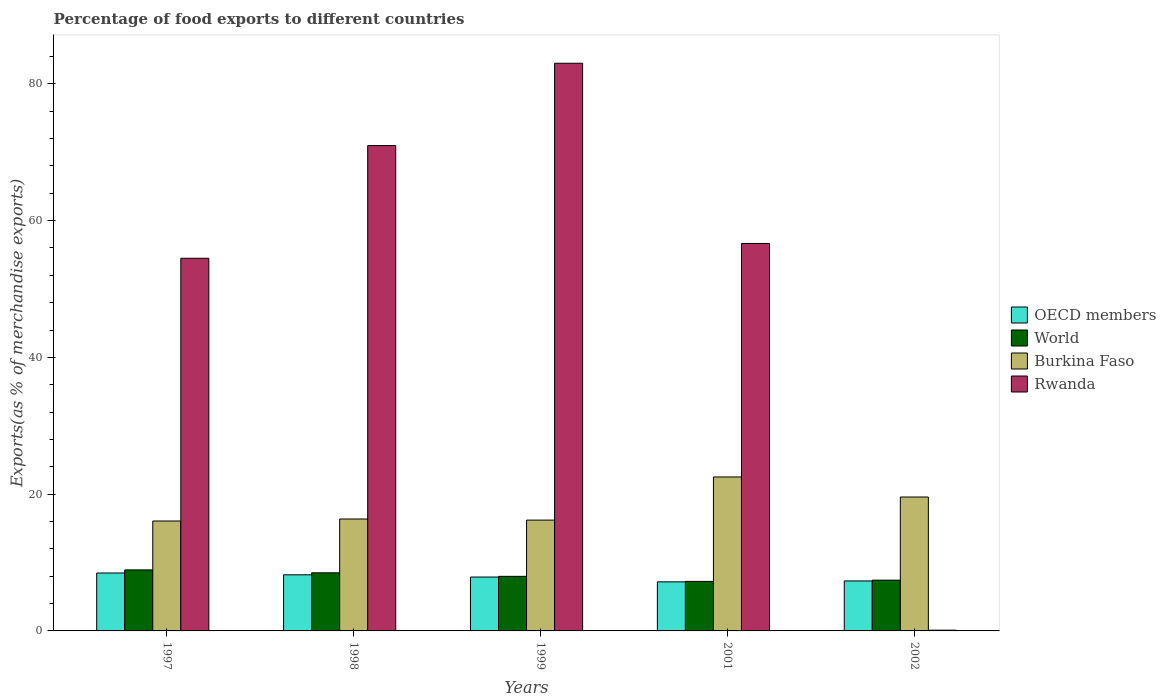How many different coloured bars are there?
Keep it short and to the point. 4. How many groups of bars are there?
Make the answer very short. 5. How many bars are there on the 1st tick from the left?
Ensure brevity in your answer.  4. What is the percentage of exports to different countries in Burkina Faso in 2002?
Make the answer very short. 19.58. Across all years, what is the maximum percentage of exports to different countries in Burkina Faso?
Make the answer very short. 22.51. Across all years, what is the minimum percentage of exports to different countries in Burkina Faso?
Provide a short and direct response. 16.07. In which year was the percentage of exports to different countries in OECD members minimum?
Provide a short and direct response. 2001. What is the total percentage of exports to different countries in World in the graph?
Your answer should be very brief. 40.06. What is the difference between the percentage of exports to different countries in Rwanda in 1997 and that in 2001?
Your response must be concise. -2.16. What is the difference between the percentage of exports to different countries in Rwanda in 1997 and the percentage of exports to different countries in OECD members in 2001?
Give a very brief answer. 47.32. What is the average percentage of exports to different countries in Rwanda per year?
Your response must be concise. 53.05. In the year 1999, what is the difference between the percentage of exports to different countries in OECD members and percentage of exports to different countries in Burkina Faso?
Provide a succinct answer. -8.33. What is the ratio of the percentage of exports to different countries in OECD members in 1997 to that in 1999?
Offer a very short reply. 1.07. Is the percentage of exports to different countries in Burkina Faso in 1998 less than that in 2001?
Your response must be concise. Yes. Is the difference between the percentage of exports to different countries in OECD members in 2001 and 2002 greater than the difference between the percentage of exports to different countries in Burkina Faso in 2001 and 2002?
Provide a succinct answer. No. What is the difference between the highest and the second highest percentage of exports to different countries in OECD members?
Offer a very short reply. 0.26. What is the difference between the highest and the lowest percentage of exports to different countries in World?
Give a very brief answer. 1.68. Is the sum of the percentage of exports to different countries in Rwanda in 2001 and 2002 greater than the maximum percentage of exports to different countries in OECD members across all years?
Offer a very short reply. Yes. What does the 2nd bar from the left in 2002 represents?
Your answer should be compact. World. What does the 2nd bar from the right in 1999 represents?
Offer a terse response. Burkina Faso. How many bars are there?
Offer a terse response. 20. Are all the bars in the graph horizontal?
Provide a succinct answer. No. How many years are there in the graph?
Your answer should be compact. 5. Are the values on the major ticks of Y-axis written in scientific E-notation?
Keep it short and to the point. No. How are the legend labels stacked?
Your answer should be compact. Vertical. What is the title of the graph?
Keep it short and to the point. Percentage of food exports to different countries. What is the label or title of the X-axis?
Ensure brevity in your answer.  Years. What is the label or title of the Y-axis?
Make the answer very short. Exports(as % of merchandise exports). What is the Exports(as % of merchandise exports) of OECD members in 1997?
Your response must be concise. 8.47. What is the Exports(as % of merchandise exports) of World in 1997?
Offer a terse response. 8.92. What is the Exports(as % of merchandise exports) in Burkina Faso in 1997?
Your response must be concise. 16.07. What is the Exports(as % of merchandise exports) in Rwanda in 1997?
Your answer should be very brief. 54.49. What is the Exports(as % of merchandise exports) in OECD members in 1998?
Make the answer very short. 8.2. What is the Exports(as % of merchandise exports) of World in 1998?
Provide a succinct answer. 8.5. What is the Exports(as % of merchandise exports) in Burkina Faso in 1998?
Provide a succinct answer. 16.37. What is the Exports(as % of merchandise exports) in Rwanda in 1998?
Provide a short and direct response. 70.97. What is the Exports(as % of merchandise exports) of OECD members in 1999?
Your response must be concise. 7.88. What is the Exports(as % of merchandise exports) in World in 1999?
Give a very brief answer. 7.98. What is the Exports(as % of merchandise exports) of Burkina Faso in 1999?
Provide a succinct answer. 16.2. What is the Exports(as % of merchandise exports) of Rwanda in 1999?
Your answer should be very brief. 83.01. What is the Exports(as % of merchandise exports) in OECD members in 2001?
Offer a terse response. 7.17. What is the Exports(as % of merchandise exports) of World in 2001?
Keep it short and to the point. 7.24. What is the Exports(as % of merchandise exports) in Burkina Faso in 2001?
Keep it short and to the point. 22.51. What is the Exports(as % of merchandise exports) in Rwanda in 2001?
Offer a terse response. 56.66. What is the Exports(as % of merchandise exports) of OECD members in 2002?
Offer a terse response. 7.31. What is the Exports(as % of merchandise exports) of World in 2002?
Provide a short and direct response. 7.42. What is the Exports(as % of merchandise exports) of Burkina Faso in 2002?
Ensure brevity in your answer.  19.58. What is the Exports(as % of merchandise exports) of Rwanda in 2002?
Give a very brief answer. 0.11. Across all years, what is the maximum Exports(as % of merchandise exports) in OECD members?
Offer a terse response. 8.47. Across all years, what is the maximum Exports(as % of merchandise exports) of World?
Make the answer very short. 8.92. Across all years, what is the maximum Exports(as % of merchandise exports) of Burkina Faso?
Ensure brevity in your answer.  22.51. Across all years, what is the maximum Exports(as % of merchandise exports) in Rwanda?
Give a very brief answer. 83.01. Across all years, what is the minimum Exports(as % of merchandise exports) of OECD members?
Your answer should be very brief. 7.17. Across all years, what is the minimum Exports(as % of merchandise exports) of World?
Your response must be concise. 7.24. Across all years, what is the minimum Exports(as % of merchandise exports) in Burkina Faso?
Keep it short and to the point. 16.07. Across all years, what is the minimum Exports(as % of merchandise exports) in Rwanda?
Your answer should be very brief. 0.11. What is the total Exports(as % of merchandise exports) in OECD members in the graph?
Your response must be concise. 39.04. What is the total Exports(as % of merchandise exports) of World in the graph?
Offer a very short reply. 40.06. What is the total Exports(as % of merchandise exports) in Burkina Faso in the graph?
Offer a terse response. 90.74. What is the total Exports(as % of merchandise exports) in Rwanda in the graph?
Offer a terse response. 265.23. What is the difference between the Exports(as % of merchandise exports) of OECD members in 1997 and that in 1998?
Your answer should be very brief. 0.26. What is the difference between the Exports(as % of merchandise exports) of World in 1997 and that in 1998?
Give a very brief answer. 0.43. What is the difference between the Exports(as % of merchandise exports) of Burkina Faso in 1997 and that in 1998?
Give a very brief answer. -0.29. What is the difference between the Exports(as % of merchandise exports) of Rwanda in 1997 and that in 1998?
Offer a terse response. -16.48. What is the difference between the Exports(as % of merchandise exports) of OECD members in 1997 and that in 1999?
Your response must be concise. 0.59. What is the difference between the Exports(as % of merchandise exports) of Burkina Faso in 1997 and that in 1999?
Provide a succinct answer. -0.13. What is the difference between the Exports(as % of merchandise exports) of Rwanda in 1997 and that in 1999?
Give a very brief answer. -28.51. What is the difference between the Exports(as % of merchandise exports) of OECD members in 1997 and that in 2001?
Give a very brief answer. 1.29. What is the difference between the Exports(as % of merchandise exports) of World in 1997 and that in 2001?
Your answer should be very brief. 1.68. What is the difference between the Exports(as % of merchandise exports) in Burkina Faso in 1997 and that in 2001?
Give a very brief answer. -6.44. What is the difference between the Exports(as % of merchandise exports) of Rwanda in 1997 and that in 2001?
Ensure brevity in your answer.  -2.16. What is the difference between the Exports(as % of merchandise exports) in OECD members in 1997 and that in 2002?
Make the answer very short. 1.16. What is the difference between the Exports(as % of merchandise exports) of World in 1997 and that in 2002?
Offer a very short reply. 1.5. What is the difference between the Exports(as % of merchandise exports) in Burkina Faso in 1997 and that in 2002?
Keep it short and to the point. -3.51. What is the difference between the Exports(as % of merchandise exports) in Rwanda in 1997 and that in 2002?
Provide a succinct answer. 54.38. What is the difference between the Exports(as % of merchandise exports) of OECD members in 1998 and that in 1999?
Provide a short and direct response. 0.33. What is the difference between the Exports(as % of merchandise exports) in World in 1998 and that in 1999?
Your response must be concise. 0.52. What is the difference between the Exports(as % of merchandise exports) in Burkina Faso in 1998 and that in 1999?
Offer a very short reply. 0.16. What is the difference between the Exports(as % of merchandise exports) in Rwanda in 1998 and that in 1999?
Make the answer very short. -12.04. What is the difference between the Exports(as % of merchandise exports) in OECD members in 1998 and that in 2001?
Keep it short and to the point. 1.03. What is the difference between the Exports(as % of merchandise exports) in World in 1998 and that in 2001?
Keep it short and to the point. 1.26. What is the difference between the Exports(as % of merchandise exports) in Burkina Faso in 1998 and that in 2001?
Your answer should be very brief. -6.15. What is the difference between the Exports(as % of merchandise exports) of Rwanda in 1998 and that in 2001?
Your answer should be very brief. 14.31. What is the difference between the Exports(as % of merchandise exports) of OECD members in 1998 and that in 2002?
Offer a terse response. 0.9. What is the difference between the Exports(as % of merchandise exports) of World in 1998 and that in 2002?
Offer a very short reply. 1.07. What is the difference between the Exports(as % of merchandise exports) of Burkina Faso in 1998 and that in 2002?
Provide a short and direct response. -3.21. What is the difference between the Exports(as % of merchandise exports) of Rwanda in 1998 and that in 2002?
Ensure brevity in your answer.  70.86. What is the difference between the Exports(as % of merchandise exports) in OECD members in 1999 and that in 2001?
Offer a very short reply. 0.7. What is the difference between the Exports(as % of merchandise exports) in World in 1999 and that in 2001?
Make the answer very short. 0.74. What is the difference between the Exports(as % of merchandise exports) in Burkina Faso in 1999 and that in 2001?
Your answer should be compact. -6.31. What is the difference between the Exports(as % of merchandise exports) in Rwanda in 1999 and that in 2001?
Give a very brief answer. 26.35. What is the difference between the Exports(as % of merchandise exports) in OECD members in 1999 and that in 2002?
Offer a very short reply. 0.57. What is the difference between the Exports(as % of merchandise exports) in World in 1999 and that in 2002?
Your answer should be compact. 0.55. What is the difference between the Exports(as % of merchandise exports) of Burkina Faso in 1999 and that in 2002?
Ensure brevity in your answer.  -3.38. What is the difference between the Exports(as % of merchandise exports) of Rwanda in 1999 and that in 2002?
Your answer should be very brief. 82.9. What is the difference between the Exports(as % of merchandise exports) in OECD members in 2001 and that in 2002?
Provide a short and direct response. -0.13. What is the difference between the Exports(as % of merchandise exports) of World in 2001 and that in 2002?
Your answer should be very brief. -0.19. What is the difference between the Exports(as % of merchandise exports) of Burkina Faso in 2001 and that in 2002?
Ensure brevity in your answer.  2.93. What is the difference between the Exports(as % of merchandise exports) of Rwanda in 2001 and that in 2002?
Provide a short and direct response. 56.55. What is the difference between the Exports(as % of merchandise exports) of OECD members in 1997 and the Exports(as % of merchandise exports) of World in 1998?
Keep it short and to the point. -0.03. What is the difference between the Exports(as % of merchandise exports) in OECD members in 1997 and the Exports(as % of merchandise exports) in Burkina Faso in 1998?
Your answer should be very brief. -7.9. What is the difference between the Exports(as % of merchandise exports) in OECD members in 1997 and the Exports(as % of merchandise exports) in Rwanda in 1998?
Offer a very short reply. -62.5. What is the difference between the Exports(as % of merchandise exports) in World in 1997 and the Exports(as % of merchandise exports) in Burkina Faso in 1998?
Keep it short and to the point. -7.44. What is the difference between the Exports(as % of merchandise exports) of World in 1997 and the Exports(as % of merchandise exports) of Rwanda in 1998?
Make the answer very short. -62.05. What is the difference between the Exports(as % of merchandise exports) of Burkina Faso in 1997 and the Exports(as % of merchandise exports) of Rwanda in 1998?
Provide a short and direct response. -54.9. What is the difference between the Exports(as % of merchandise exports) of OECD members in 1997 and the Exports(as % of merchandise exports) of World in 1999?
Provide a succinct answer. 0.49. What is the difference between the Exports(as % of merchandise exports) of OECD members in 1997 and the Exports(as % of merchandise exports) of Burkina Faso in 1999?
Offer a very short reply. -7.74. What is the difference between the Exports(as % of merchandise exports) in OECD members in 1997 and the Exports(as % of merchandise exports) in Rwanda in 1999?
Give a very brief answer. -74.54. What is the difference between the Exports(as % of merchandise exports) in World in 1997 and the Exports(as % of merchandise exports) in Burkina Faso in 1999?
Your answer should be compact. -7.28. What is the difference between the Exports(as % of merchandise exports) in World in 1997 and the Exports(as % of merchandise exports) in Rwanda in 1999?
Ensure brevity in your answer.  -74.08. What is the difference between the Exports(as % of merchandise exports) in Burkina Faso in 1997 and the Exports(as % of merchandise exports) in Rwanda in 1999?
Offer a terse response. -66.93. What is the difference between the Exports(as % of merchandise exports) of OECD members in 1997 and the Exports(as % of merchandise exports) of World in 2001?
Provide a succinct answer. 1.23. What is the difference between the Exports(as % of merchandise exports) of OECD members in 1997 and the Exports(as % of merchandise exports) of Burkina Faso in 2001?
Provide a succinct answer. -14.04. What is the difference between the Exports(as % of merchandise exports) in OECD members in 1997 and the Exports(as % of merchandise exports) in Rwanda in 2001?
Give a very brief answer. -48.19. What is the difference between the Exports(as % of merchandise exports) of World in 1997 and the Exports(as % of merchandise exports) of Burkina Faso in 2001?
Make the answer very short. -13.59. What is the difference between the Exports(as % of merchandise exports) in World in 1997 and the Exports(as % of merchandise exports) in Rwanda in 2001?
Make the answer very short. -47.73. What is the difference between the Exports(as % of merchandise exports) of Burkina Faso in 1997 and the Exports(as % of merchandise exports) of Rwanda in 2001?
Provide a short and direct response. -40.58. What is the difference between the Exports(as % of merchandise exports) of OECD members in 1997 and the Exports(as % of merchandise exports) of World in 2002?
Your answer should be very brief. 1.04. What is the difference between the Exports(as % of merchandise exports) in OECD members in 1997 and the Exports(as % of merchandise exports) in Burkina Faso in 2002?
Your answer should be compact. -11.11. What is the difference between the Exports(as % of merchandise exports) of OECD members in 1997 and the Exports(as % of merchandise exports) of Rwanda in 2002?
Offer a terse response. 8.36. What is the difference between the Exports(as % of merchandise exports) in World in 1997 and the Exports(as % of merchandise exports) in Burkina Faso in 2002?
Keep it short and to the point. -10.66. What is the difference between the Exports(as % of merchandise exports) in World in 1997 and the Exports(as % of merchandise exports) in Rwanda in 2002?
Provide a succinct answer. 8.82. What is the difference between the Exports(as % of merchandise exports) in Burkina Faso in 1997 and the Exports(as % of merchandise exports) in Rwanda in 2002?
Ensure brevity in your answer.  15.96. What is the difference between the Exports(as % of merchandise exports) of OECD members in 1998 and the Exports(as % of merchandise exports) of World in 1999?
Your response must be concise. 0.23. What is the difference between the Exports(as % of merchandise exports) of OECD members in 1998 and the Exports(as % of merchandise exports) of Burkina Faso in 1999?
Your answer should be very brief. -8. What is the difference between the Exports(as % of merchandise exports) in OECD members in 1998 and the Exports(as % of merchandise exports) in Rwanda in 1999?
Your answer should be very brief. -74.8. What is the difference between the Exports(as % of merchandise exports) of World in 1998 and the Exports(as % of merchandise exports) of Burkina Faso in 1999?
Provide a succinct answer. -7.71. What is the difference between the Exports(as % of merchandise exports) in World in 1998 and the Exports(as % of merchandise exports) in Rwanda in 1999?
Make the answer very short. -74.51. What is the difference between the Exports(as % of merchandise exports) of Burkina Faso in 1998 and the Exports(as % of merchandise exports) of Rwanda in 1999?
Provide a short and direct response. -66.64. What is the difference between the Exports(as % of merchandise exports) in OECD members in 1998 and the Exports(as % of merchandise exports) in World in 2001?
Your response must be concise. 0.96. What is the difference between the Exports(as % of merchandise exports) in OECD members in 1998 and the Exports(as % of merchandise exports) in Burkina Faso in 2001?
Provide a succinct answer. -14.31. What is the difference between the Exports(as % of merchandise exports) in OECD members in 1998 and the Exports(as % of merchandise exports) in Rwanda in 2001?
Offer a terse response. -48.45. What is the difference between the Exports(as % of merchandise exports) of World in 1998 and the Exports(as % of merchandise exports) of Burkina Faso in 2001?
Your answer should be compact. -14.02. What is the difference between the Exports(as % of merchandise exports) in World in 1998 and the Exports(as % of merchandise exports) in Rwanda in 2001?
Provide a short and direct response. -48.16. What is the difference between the Exports(as % of merchandise exports) in Burkina Faso in 1998 and the Exports(as % of merchandise exports) in Rwanda in 2001?
Ensure brevity in your answer.  -40.29. What is the difference between the Exports(as % of merchandise exports) of OECD members in 1998 and the Exports(as % of merchandise exports) of World in 2002?
Offer a very short reply. 0.78. What is the difference between the Exports(as % of merchandise exports) of OECD members in 1998 and the Exports(as % of merchandise exports) of Burkina Faso in 2002?
Give a very brief answer. -11.38. What is the difference between the Exports(as % of merchandise exports) of OECD members in 1998 and the Exports(as % of merchandise exports) of Rwanda in 2002?
Your answer should be very brief. 8.1. What is the difference between the Exports(as % of merchandise exports) of World in 1998 and the Exports(as % of merchandise exports) of Burkina Faso in 2002?
Provide a succinct answer. -11.08. What is the difference between the Exports(as % of merchandise exports) of World in 1998 and the Exports(as % of merchandise exports) of Rwanda in 2002?
Your response must be concise. 8.39. What is the difference between the Exports(as % of merchandise exports) of Burkina Faso in 1998 and the Exports(as % of merchandise exports) of Rwanda in 2002?
Provide a short and direct response. 16.26. What is the difference between the Exports(as % of merchandise exports) of OECD members in 1999 and the Exports(as % of merchandise exports) of World in 2001?
Provide a succinct answer. 0.64. What is the difference between the Exports(as % of merchandise exports) of OECD members in 1999 and the Exports(as % of merchandise exports) of Burkina Faso in 2001?
Your response must be concise. -14.63. What is the difference between the Exports(as % of merchandise exports) of OECD members in 1999 and the Exports(as % of merchandise exports) of Rwanda in 2001?
Keep it short and to the point. -48.78. What is the difference between the Exports(as % of merchandise exports) in World in 1999 and the Exports(as % of merchandise exports) in Burkina Faso in 2001?
Provide a succinct answer. -14.53. What is the difference between the Exports(as % of merchandise exports) of World in 1999 and the Exports(as % of merchandise exports) of Rwanda in 2001?
Keep it short and to the point. -48.68. What is the difference between the Exports(as % of merchandise exports) of Burkina Faso in 1999 and the Exports(as % of merchandise exports) of Rwanda in 2001?
Your answer should be very brief. -40.45. What is the difference between the Exports(as % of merchandise exports) of OECD members in 1999 and the Exports(as % of merchandise exports) of World in 2002?
Ensure brevity in your answer.  0.45. What is the difference between the Exports(as % of merchandise exports) of OECD members in 1999 and the Exports(as % of merchandise exports) of Burkina Faso in 2002?
Ensure brevity in your answer.  -11.7. What is the difference between the Exports(as % of merchandise exports) in OECD members in 1999 and the Exports(as % of merchandise exports) in Rwanda in 2002?
Your answer should be very brief. 7.77. What is the difference between the Exports(as % of merchandise exports) of World in 1999 and the Exports(as % of merchandise exports) of Burkina Faso in 2002?
Provide a short and direct response. -11.6. What is the difference between the Exports(as % of merchandise exports) of World in 1999 and the Exports(as % of merchandise exports) of Rwanda in 2002?
Your response must be concise. 7.87. What is the difference between the Exports(as % of merchandise exports) in Burkina Faso in 1999 and the Exports(as % of merchandise exports) in Rwanda in 2002?
Ensure brevity in your answer.  16.1. What is the difference between the Exports(as % of merchandise exports) of OECD members in 2001 and the Exports(as % of merchandise exports) of World in 2002?
Your answer should be compact. -0.25. What is the difference between the Exports(as % of merchandise exports) of OECD members in 2001 and the Exports(as % of merchandise exports) of Burkina Faso in 2002?
Offer a terse response. -12.41. What is the difference between the Exports(as % of merchandise exports) in OECD members in 2001 and the Exports(as % of merchandise exports) in Rwanda in 2002?
Give a very brief answer. 7.07. What is the difference between the Exports(as % of merchandise exports) of World in 2001 and the Exports(as % of merchandise exports) of Burkina Faso in 2002?
Keep it short and to the point. -12.34. What is the difference between the Exports(as % of merchandise exports) of World in 2001 and the Exports(as % of merchandise exports) of Rwanda in 2002?
Offer a terse response. 7.13. What is the difference between the Exports(as % of merchandise exports) of Burkina Faso in 2001 and the Exports(as % of merchandise exports) of Rwanda in 2002?
Your answer should be compact. 22.4. What is the average Exports(as % of merchandise exports) in OECD members per year?
Offer a very short reply. 7.81. What is the average Exports(as % of merchandise exports) in World per year?
Your answer should be very brief. 8.01. What is the average Exports(as % of merchandise exports) of Burkina Faso per year?
Your answer should be compact. 18.15. What is the average Exports(as % of merchandise exports) of Rwanda per year?
Give a very brief answer. 53.05. In the year 1997, what is the difference between the Exports(as % of merchandise exports) of OECD members and Exports(as % of merchandise exports) of World?
Provide a short and direct response. -0.46. In the year 1997, what is the difference between the Exports(as % of merchandise exports) of OECD members and Exports(as % of merchandise exports) of Burkina Faso?
Provide a short and direct response. -7.6. In the year 1997, what is the difference between the Exports(as % of merchandise exports) in OECD members and Exports(as % of merchandise exports) in Rwanda?
Provide a succinct answer. -46.02. In the year 1997, what is the difference between the Exports(as % of merchandise exports) in World and Exports(as % of merchandise exports) in Burkina Faso?
Give a very brief answer. -7.15. In the year 1997, what is the difference between the Exports(as % of merchandise exports) in World and Exports(as % of merchandise exports) in Rwanda?
Your response must be concise. -45.57. In the year 1997, what is the difference between the Exports(as % of merchandise exports) in Burkina Faso and Exports(as % of merchandise exports) in Rwanda?
Keep it short and to the point. -38.42. In the year 1998, what is the difference between the Exports(as % of merchandise exports) of OECD members and Exports(as % of merchandise exports) of World?
Offer a terse response. -0.29. In the year 1998, what is the difference between the Exports(as % of merchandise exports) in OECD members and Exports(as % of merchandise exports) in Burkina Faso?
Offer a terse response. -8.16. In the year 1998, what is the difference between the Exports(as % of merchandise exports) of OECD members and Exports(as % of merchandise exports) of Rwanda?
Offer a terse response. -62.76. In the year 1998, what is the difference between the Exports(as % of merchandise exports) of World and Exports(as % of merchandise exports) of Burkina Faso?
Give a very brief answer. -7.87. In the year 1998, what is the difference between the Exports(as % of merchandise exports) in World and Exports(as % of merchandise exports) in Rwanda?
Offer a very short reply. -62.47. In the year 1998, what is the difference between the Exports(as % of merchandise exports) in Burkina Faso and Exports(as % of merchandise exports) in Rwanda?
Offer a very short reply. -54.6. In the year 1999, what is the difference between the Exports(as % of merchandise exports) in OECD members and Exports(as % of merchandise exports) in World?
Offer a terse response. -0.1. In the year 1999, what is the difference between the Exports(as % of merchandise exports) of OECD members and Exports(as % of merchandise exports) of Burkina Faso?
Ensure brevity in your answer.  -8.33. In the year 1999, what is the difference between the Exports(as % of merchandise exports) in OECD members and Exports(as % of merchandise exports) in Rwanda?
Provide a succinct answer. -75.13. In the year 1999, what is the difference between the Exports(as % of merchandise exports) of World and Exports(as % of merchandise exports) of Burkina Faso?
Offer a terse response. -8.23. In the year 1999, what is the difference between the Exports(as % of merchandise exports) in World and Exports(as % of merchandise exports) in Rwanda?
Make the answer very short. -75.03. In the year 1999, what is the difference between the Exports(as % of merchandise exports) in Burkina Faso and Exports(as % of merchandise exports) in Rwanda?
Give a very brief answer. -66.8. In the year 2001, what is the difference between the Exports(as % of merchandise exports) of OECD members and Exports(as % of merchandise exports) of World?
Offer a very short reply. -0.07. In the year 2001, what is the difference between the Exports(as % of merchandise exports) of OECD members and Exports(as % of merchandise exports) of Burkina Faso?
Make the answer very short. -15.34. In the year 2001, what is the difference between the Exports(as % of merchandise exports) in OECD members and Exports(as % of merchandise exports) in Rwanda?
Give a very brief answer. -49.48. In the year 2001, what is the difference between the Exports(as % of merchandise exports) in World and Exports(as % of merchandise exports) in Burkina Faso?
Offer a terse response. -15.27. In the year 2001, what is the difference between the Exports(as % of merchandise exports) in World and Exports(as % of merchandise exports) in Rwanda?
Your answer should be compact. -49.42. In the year 2001, what is the difference between the Exports(as % of merchandise exports) in Burkina Faso and Exports(as % of merchandise exports) in Rwanda?
Give a very brief answer. -34.14. In the year 2002, what is the difference between the Exports(as % of merchandise exports) in OECD members and Exports(as % of merchandise exports) in World?
Offer a very short reply. -0.12. In the year 2002, what is the difference between the Exports(as % of merchandise exports) of OECD members and Exports(as % of merchandise exports) of Burkina Faso?
Give a very brief answer. -12.27. In the year 2002, what is the difference between the Exports(as % of merchandise exports) of OECD members and Exports(as % of merchandise exports) of Rwanda?
Keep it short and to the point. 7.2. In the year 2002, what is the difference between the Exports(as % of merchandise exports) of World and Exports(as % of merchandise exports) of Burkina Faso?
Keep it short and to the point. -12.16. In the year 2002, what is the difference between the Exports(as % of merchandise exports) of World and Exports(as % of merchandise exports) of Rwanda?
Ensure brevity in your answer.  7.32. In the year 2002, what is the difference between the Exports(as % of merchandise exports) of Burkina Faso and Exports(as % of merchandise exports) of Rwanda?
Give a very brief answer. 19.47. What is the ratio of the Exports(as % of merchandise exports) of OECD members in 1997 to that in 1998?
Offer a terse response. 1.03. What is the ratio of the Exports(as % of merchandise exports) of World in 1997 to that in 1998?
Your answer should be compact. 1.05. What is the ratio of the Exports(as % of merchandise exports) in Burkina Faso in 1997 to that in 1998?
Your answer should be compact. 0.98. What is the ratio of the Exports(as % of merchandise exports) of Rwanda in 1997 to that in 1998?
Give a very brief answer. 0.77. What is the ratio of the Exports(as % of merchandise exports) in OECD members in 1997 to that in 1999?
Make the answer very short. 1.07. What is the ratio of the Exports(as % of merchandise exports) of World in 1997 to that in 1999?
Ensure brevity in your answer.  1.12. What is the ratio of the Exports(as % of merchandise exports) in Burkina Faso in 1997 to that in 1999?
Your answer should be compact. 0.99. What is the ratio of the Exports(as % of merchandise exports) in Rwanda in 1997 to that in 1999?
Your answer should be compact. 0.66. What is the ratio of the Exports(as % of merchandise exports) of OECD members in 1997 to that in 2001?
Keep it short and to the point. 1.18. What is the ratio of the Exports(as % of merchandise exports) in World in 1997 to that in 2001?
Offer a very short reply. 1.23. What is the ratio of the Exports(as % of merchandise exports) of Burkina Faso in 1997 to that in 2001?
Offer a very short reply. 0.71. What is the ratio of the Exports(as % of merchandise exports) of Rwanda in 1997 to that in 2001?
Your answer should be very brief. 0.96. What is the ratio of the Exports(as % of merchandise exports) of OECD members in 1997 to that in 2002?
Give a very brief answer. 1.16. What is the ratio of the Exports(as % of merchandise exports) of World in 1997 to that in 2002?
Your answer should be compact. 1.2. What is the ratio of the Exports(as % of merchandise exports) in Burkina Faso in 1997 to that in 2002?
Your answer should be compact. 0.82. What is the ratio of the Exports(as % of merchandise exports) in Rwanda in 1997 to that in 2002?
Your answer should be compact. 502.4. What is the ratio of the Exports(as % of merchandise exports) in OECD members in 1998 to that in 1999?
Make the answer very short. 1.04. What is the ratio of the Exports(as % of merchandise exports) of World in 1998 to that in 1999?
Provide a succinct answer. 1.06. What is the ratio of the Exports(as % of merchandise exports) in Rwanda in 1998 to that in 1999?
Ensure brevity in your answer.  0.85. What is the ratio of the Exports(as % of merchandise exports) of OECD members in 1998 to that in 2001?
Make the answer very short. 1.14. What is the ratio of the Exports(as % of merchandise exports) in World in 1998 to that in 2001?
Your answer should be compact. 1.17. What is the ratio of the Exports(as % of merchandise exports) of Burkina Faso in 1998 to that in 2001?
Make the answer very short. 0.73. What is the ratio of the Exports(as % of merchandise exports) in Rwanda in 1998 to that in 2001?
Provide a short and direct response. 1.25. What is the ratio of the Exports(as % of merchandise exports) of OECD members in 1998 to that in 2002?
Provide a succinct answer. 1.12. What is the ratio of the Exports(as % of merchandise exports) in World in 1998 to that in 2002?
Ensure brevity in your answer.  1.14. What is the ratio of the Exports(as % of merchandise exports) in Burkina Faso in 1998 to that in 2002?
Make the answer very short. 0.84. What is the ratio of the Exports(as % of merchandise exports) of Rwanda in 1998 to that in 2002?
Ensure brevity in your answer.  654.31. What is the ratio of the Exports(as % of merchandise exports) of OECD members in 1999 to that in 2001?
Offer a terse response. 1.1. What is the ratio of the Exports(as % of merchandise exports) in World in 1999 to that in 2001?
Provide a succinct answer. 1.1. What is the ratio of the Exports(as % of merchandise exports) in Burkina Faso in 1999 to that in 2001?
Provide a succinct answer. 0.72. What is the ratio of the Exports(as % of merchandise exports) of Rwanda in 1999 to that in 2001?
Your answer should be very brief. 1.47. What is the ratio of the Exports(as % of merchandise exports) in OECD members in 1999 to that in 2002?
Provide a succinct answer. 1.08. What is the ratio of the Exports(as % of merchandise exports) of World in 1999 to that in 2002?
Ensure brevity in your answer.  1.07. What is the ratio of the Exports(as % of merchandise exports) in Burkina Faso in 1999 to that in 2002?
Make the answer very short. 0.83. What is the ratio of the Exports(as % of merchandise exports) in Rwanda in 1999 to that in 2002?
Your response must be concise. 765.3. What is the ratio of the Exports(as % of merchandise exports) in OECD members in 2001 to that in 2002?
Provide a short and direct response. 0.98. What is the ratio of the Exports(as % of merchandise exports) of Burkina Faso in 2001 to that in 2002?
Offer a very short reply. 1.15. What is the ratio of the Exports(as % of merchandise exports) in Rwanda in 2001 to that in 2002?
Offer a terse response. 522.35. What is the difference between the highest and the second highest Exports(as % of merchandise exports) in OECD members?
Offer a terse response. 0.26. What is the difference between the highest and the second highest Exports(as % of merchandise exports) of World?
Provide a succinct answer. 0.43. What is the difference between the highest and the second highest Exports(as % of merchandise exports) of Burkina Faso?
Your response must be concise. 2.93. What is the difference between the highest and the second highest Exports(as % of merchandise exports) in Rwanda?
Keep it short and to the point. 12.04. What is the difference between the highest and the lowest Exports(as % of merchandise exports) in OECD members?
Keep it short and to the point. 1.29. What is the difference between the highest and the lowest Exports(as % of merchandise exports) of World?
Your answer should be compact. 1.68. What is the difference between the highest and the lowest Exports(as % of merchandise exports) of Burkina Faso?
Make the answer very short. 6.44. What is the difference between the highest and the lowest Exports(as % of merchandise exports) of Rwanda?
Offer a very short reply. 82.9. 